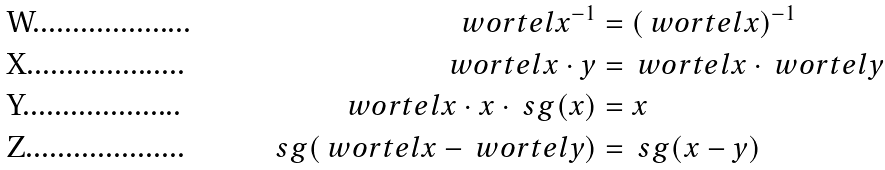Convert formula to latex. <formula><loc_0><loc_0><loc_500><loc_500>\ w o r t e l { x ^ { - 1 } } & = ( \ w o r t e l { x } ) ^ { - 1 } \\ \ w o r t e l { x \cdot y } & = \ w o r t e l { x } \cdot \ w o r t e l { y } \\ \ w o r t e l { x \cdot x \cdot \ s g ( x ) } & = x \\ \ s g ( \ w o r t e l { x } - \ w o r t e l { y } ) & = \ s g ( x - y )</formula> 